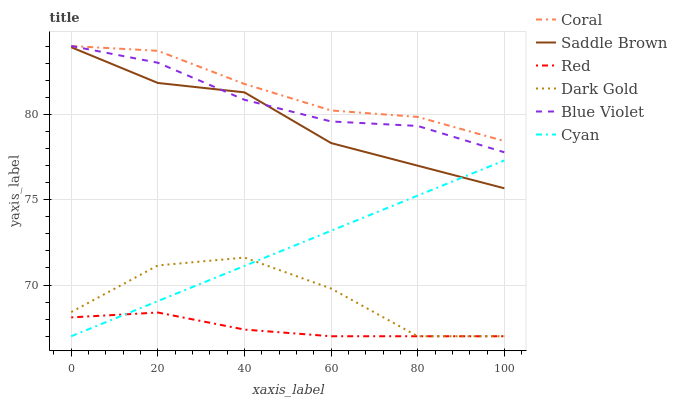Does Red have the minimum area under the curve?
Answer yes or no. Yes. Does Coral have the maximum area under the curve?
Answer yes or no. Yes. Does Coral have the minimum area under the curve?
Answer yes or no. No. Does Red have the maximum area under the curve?
Answer yes or no. No. Is Cyan the smoothest?
Answer yes or no. Yes. Is Dark Gold the roughest?
Answer yes or no. Yes. Is Coral the smoothest?
Answer yes or no. No. Is Coral the roughest?
Answer yes or no. No. Does Coral have the lowest value?
Answer yes or no. No. Does Blue Violet have the highest value?
Answer yes or no. Yes. Does Red have the highest value?
Answer yes or no. No. Is Red less than Blue Violet?
Answer yes or no. Yes. Is Blue Violet greater than Cyan?
Answer yes or no. Yes. Does Blue Violet intersect Coral?
Answer yes or no. Yes. Is Blue Violet less than Coral?
Answer yes or no. No. Is Blue Violet greater than Coral?
Answer yes or no. No. Does Red intersect Blue Violet?
Answer yes or no. No. 